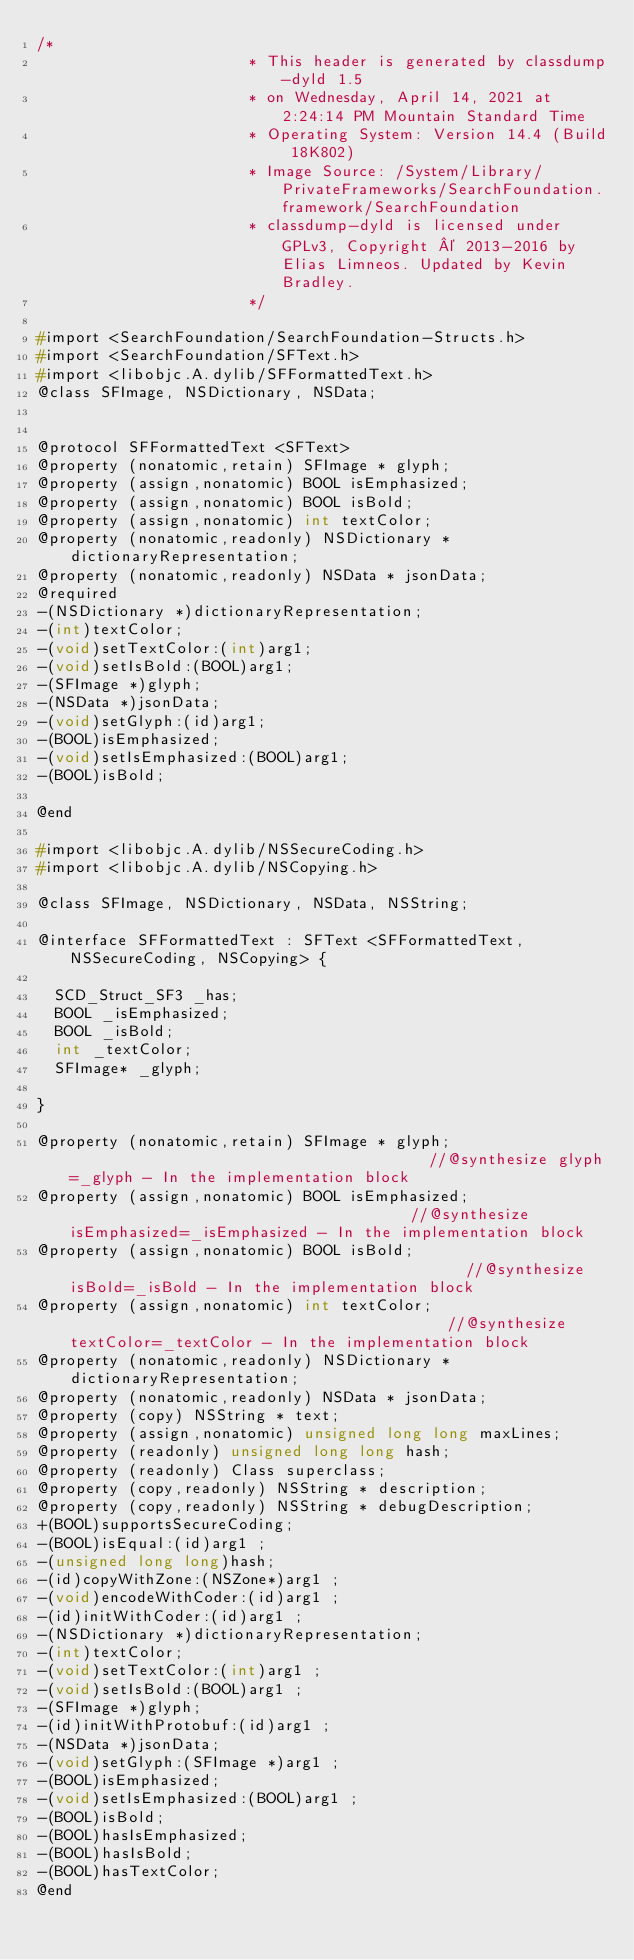<code> <loc_0><loc_0><loc_500><loc_500><_C_>/*
                       * This header is generated by classdump-dyld 1.5
                       * on Wednesday, April 14, 2021 at 2:24:14 PM Mountain Standard Time
                       * Operating System: Version 14.4 (Build 18K802)
                       * Image Source: /System/Library/PrivateFrameworks/SearchFoundation.framework/SearchFoundation
                       * classdump-dyld is licensed under GPLv3, Copyright © 2013-2016 by Elias Limneos. Updated by Kevin Bradley.
                       */

#import <SearchFoundation/SearchFoundation-Structs.h>
#import <SearchFoundation/SFText.h>
#import <libobjc.A.dylib/SFFormattedText.h>
@class SFImage, NSDictionary, NSData;


@protocol SFFormattedText <SFText>
@property (nonatomic,retain) SFImage * glyph; 
@property (assign,nonatomic) BOOL isEmphasized; 
@property (assign,nonatomic) BOOL isBold; 
@property (assign,nonatomic) int textColor; 
@property (nonatomic,readonly) NSDictionary * dictionaryRepresentation; 
@property (nonatomic,readonly) NSData * jsonData; 
@required
-(NSDictionary *)dictionaryRepresentation;
-(int)textColor;
-(void)setTextColor:(int)arg1;
-(void)setIsBold:(BOOL)arg1;
-(SFImage *)glyph;
-(NSData *)jsonData;
-(void)setGlyph:(id)arg1;
-(BOOL)isEmphasized;
-(void)setIsEmphasized:(BOOL)arg1;
-(BOOL)isBold;

@end

#import <libobjc.A.dylib/NSSecureCoding.h>
#import <libobjc.A.dylib/NSCopying.h>

@class SFImage, NSDictionary, NSData, NSString;

@interface SFFormattedText : SFText <SFFormattedText, NSSecureCoding, NSCopying> {

	SCD_Struct_SF3 _has;
	BOOL _isEmphasized;
	BOOL _isBold;
	int _textColor;
	SFImage* _glyph;

}

@property (nonatomic,retain) SFImage * glyph;                                        //@synthesize glyph=_glyph - In the implementation block
@property (assign,nonatomic) BOOL isEmphasized;                                      //@synthesize isEmphasized=_isEmphasized - In the implementation block
@property (assign,nonatomic) BOOL isBold;                                            //@synthesize isBold=_isBold - In the implementation block
@property (assign,nonatomic) int textColor;                                          //@synthesize textColor=_textColor - In the implementation block
@property (nonatomic,readonly) NSDictionary * dictionaryRepresentation; 
@property (nonatomic,readonly) NSData * jsonData; 
@property (copy) NSString * text; 
@property (assign,nonatomic) unsigned long long maxLines; 
@property (readonly) unsigned long long hash; 
@property (readonly) Class superclass; 
@property (copy,readonly) NSString * description; 
@property (copy,readonly) NSString * debugDescription; 
+(BOOL)supportsSecureCoding;
-(BOOL)isEqual:(id)arg1 ;
-(unsigned long long)hash;
-(id)copyWithZone:(NSZone*)arg1 ;
-(void)encodeWithCoder:(id)arg1 ;
-(id)initWithCoder:(id)arg1 ;
-(NSDictionary *)dictionaryRepresentation;
-(int)textColor;
-(void)setTextColor:(int)arg1 ;
-(void)setIsBold:(BOOL)arg1 ;
-(SFImage *)glyph;
-(id)initWithProtobuf:(id)arg1 ;
-(NSData *)jsonData;
-(void)setGlyph:(SFImage *)arg1 ;
-(BOOL)isEmphasized;
-(void)setIsEmphasized:(BOOL)arg1 ;
-(BOOL)isBold;
-(BOOL)hasIsEmphasized;
-(BOOL)hasIsBold;
-(BOOL)hasTextColor;
@end

</code> 